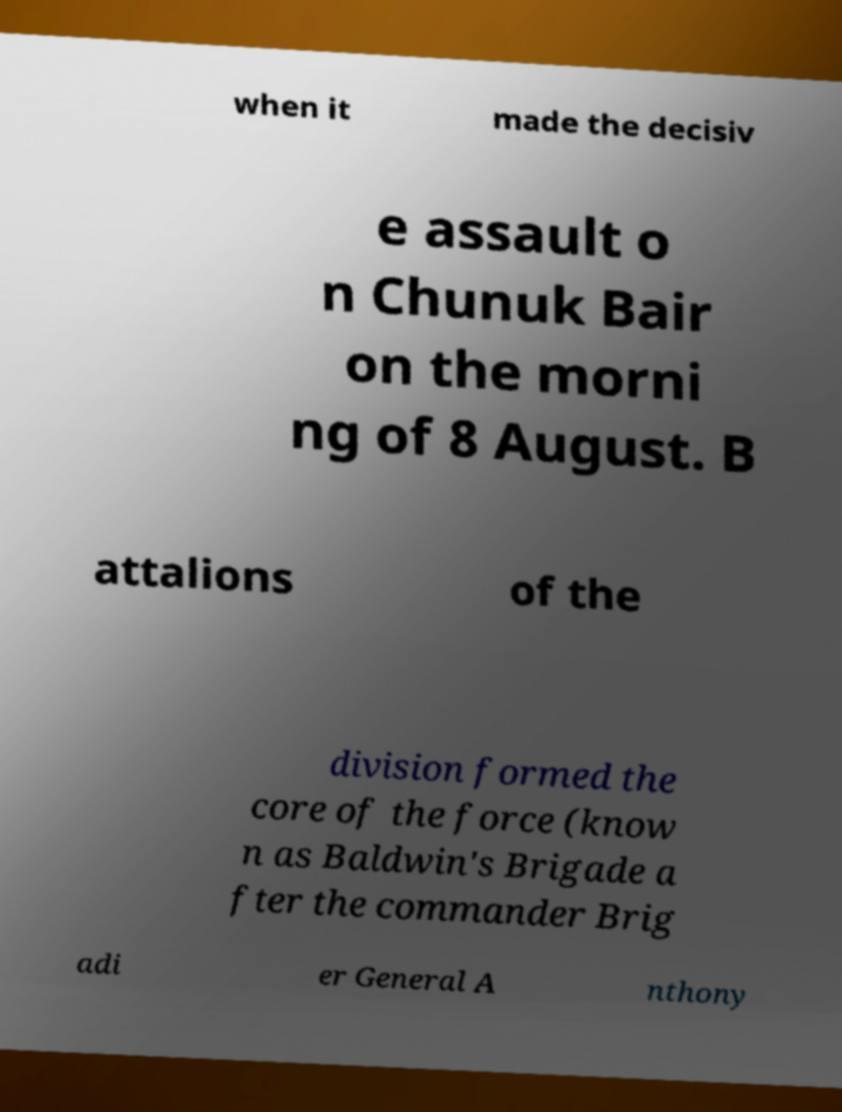Can you read and provide the text displayed in the image?This photo seems to have some interesting text. Can you extract and type it out for me? when it made the decisiv e assault o n Chunuk Bair on the morni ng of 8 August. B attalions of the division formed the core of the force (know n as Baldwin's Brigade a fter the commander Brig adi er General A nthony 